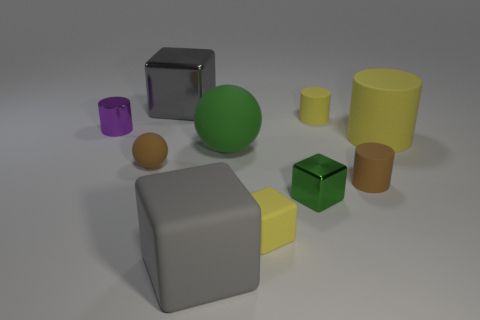Subtract all blue cylinders. How many gray blocks are left? 2 Subtract all gray matte cubes. How many cubes are left? 3 Subtract 1 blocks. How many blocks are left? 3 Subtract all brown cylinders. How many cylinders are left? 3 Subtract all balls. How many objects are left? 8 Subtract all purple metallic things. Subtract all large green matte things. How many objects are left? 8 Add 3 green things. How many green things are left? 5 Add 4 purple cylinders. How many purple cylinders exist? 5 Subtract 0 gray cylinders. How many objects are left? 10 Subtract all cyan cubes. Subtract all yellow cylinders. How many cubes are left? 4 